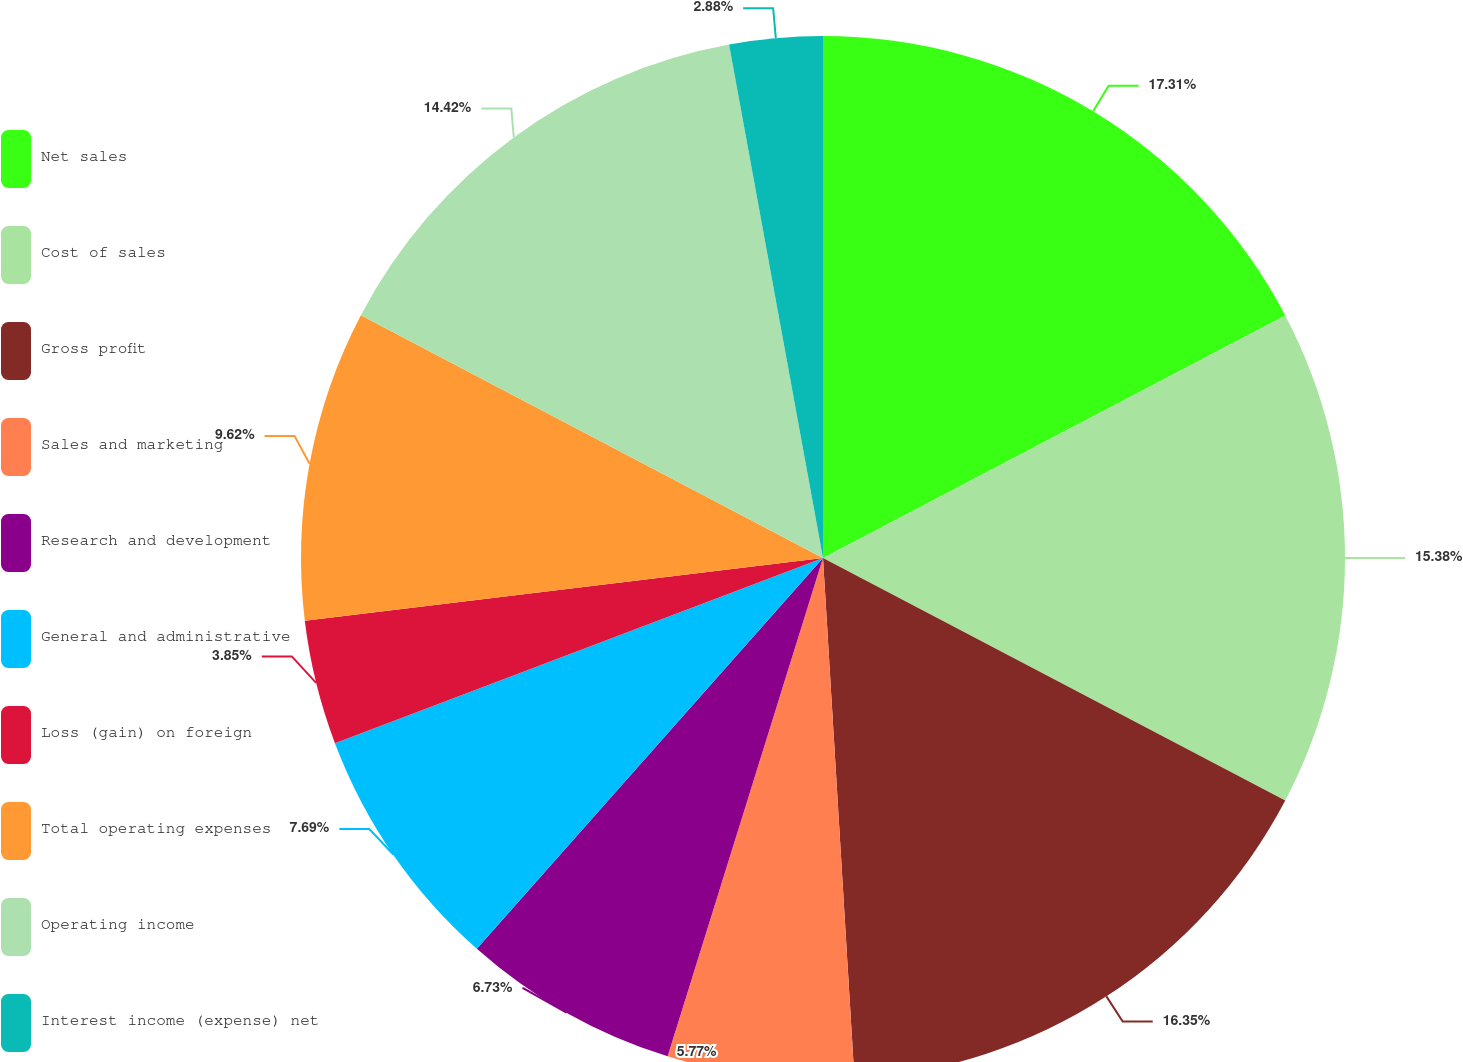<chart> <loc_0><loc_0><loc_500><loc_500><pie_chart><fcel>Net sales<fcel>Cost of sales<fcel>Gross profit<fcel>Sales and marketing<fcel>Research and development<fcel>General and administrative<fcel>Loss (gain) on foreign<fcel>Total operating expenses<fcel>Operating income<fcel>Interest income (expense) net<nl><fcel>17.31%<fcel>15.38%<fcel>16.35%<fcel>5.77%<fcel>6.73%<fcel>7.69%<fcel>3.85%<fcel>9.62%<fcel>14.42%<fcel>2.88%<nl></chart> 